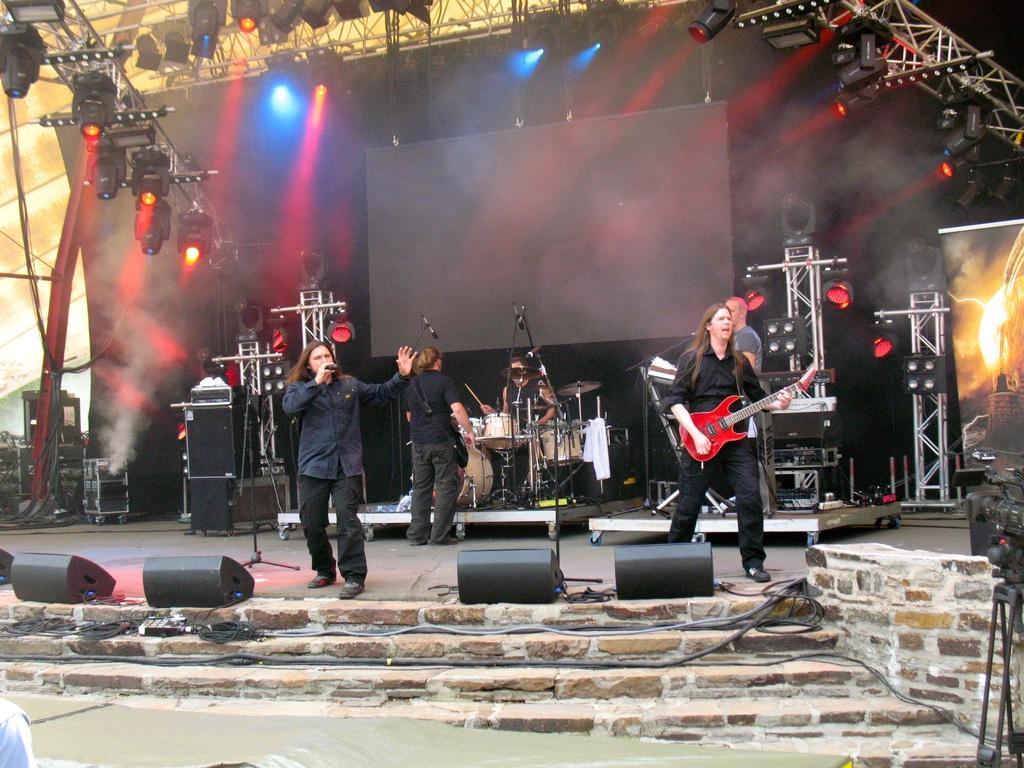Can you describe this image briefly? In this image we can see some group of persons standing on the stage playing some musical instruments and singing, there are some sound boxes, lights and in the background of the image we can see black color sheet and projector screen. 